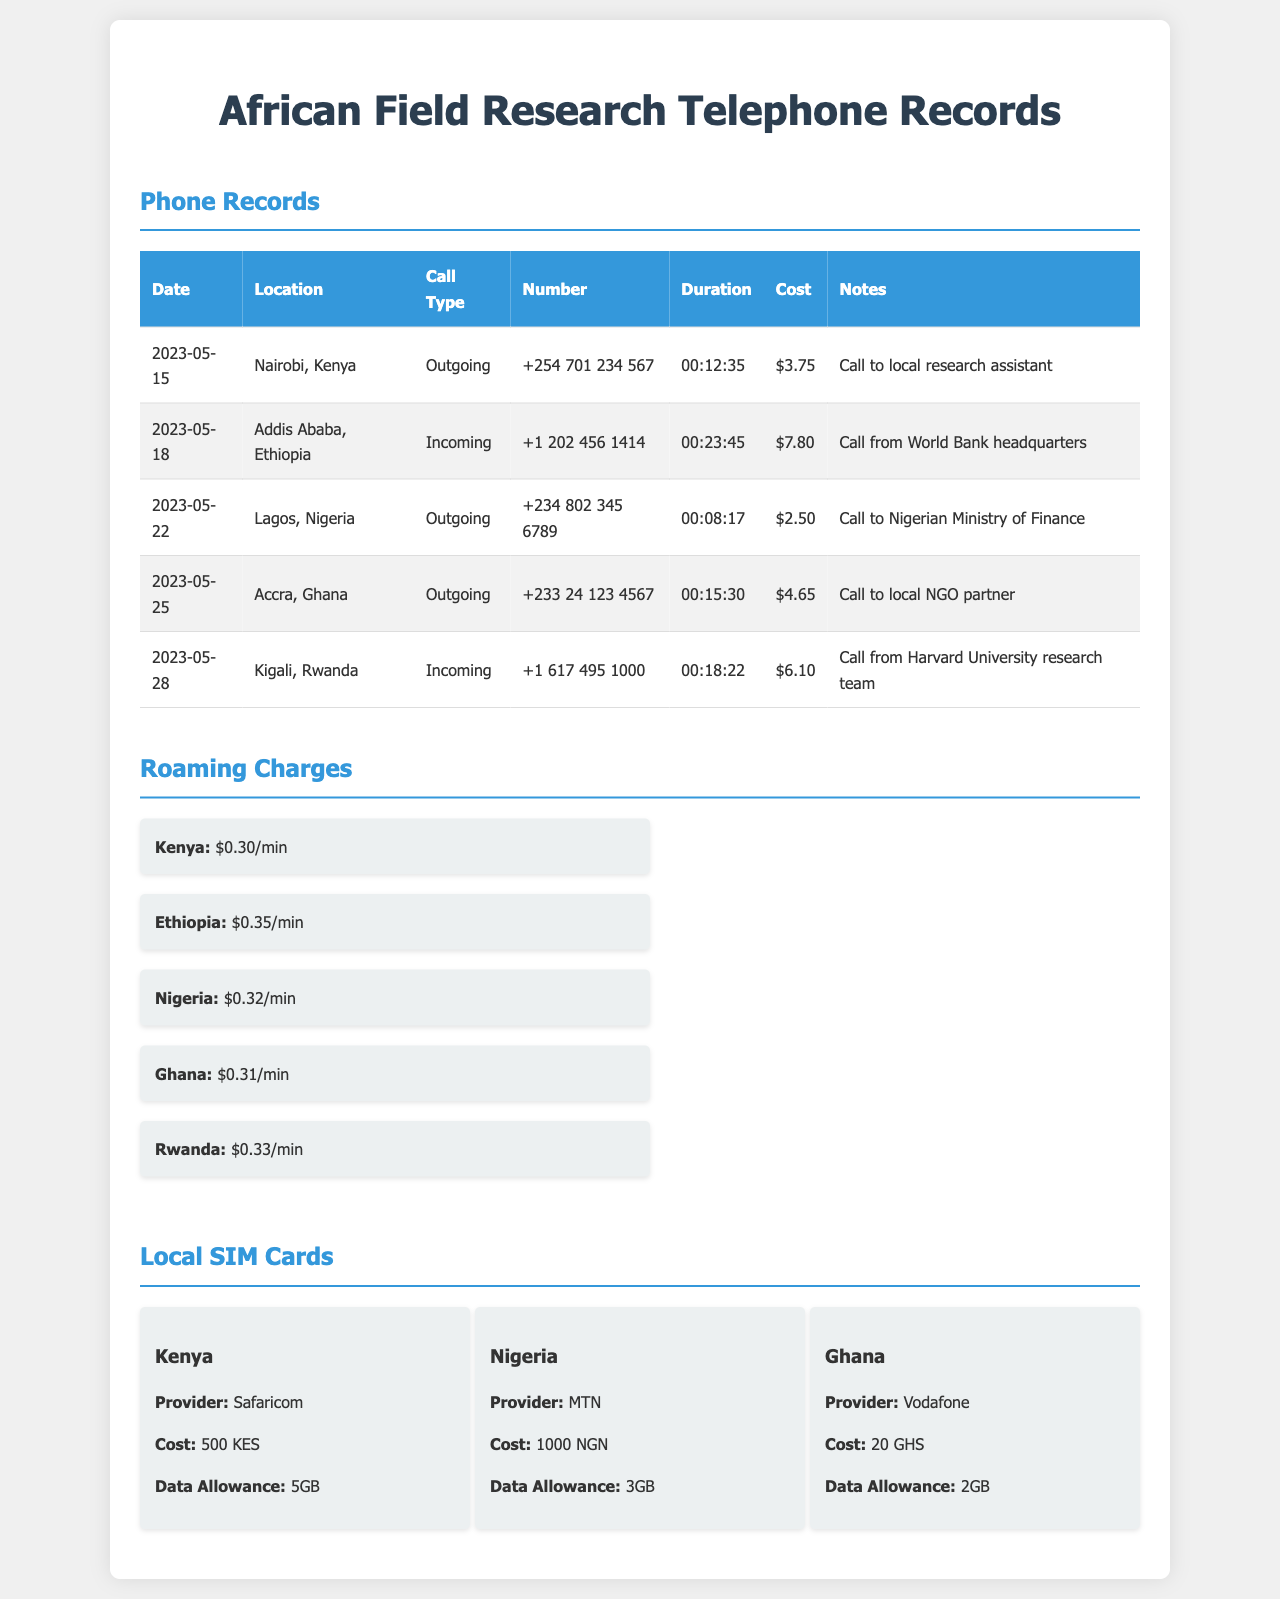What is the total cost of the call to the Nigerian Ministry of Finance? The total cost of the call to the Nigerian Ministry of Finance, made on May 22, 2023, is noted in the document.
Answer: $2.50 Which country had the highest roaming charge per minute? Comparing the roaming charges for each listed country in the document shows which one has the highest rate.
Answer: Ethiopia What was the duration of the call from Harvard University research team? The duration of the call from the Harvard University research team on May 28, 2023, is provided in the document.
Answer: 00:18:22 How much did the local SIM card in Ghana cost? The document specifies the cost of the local SIM card in Ghana.
Answer: 20 GHS What is the data allowance for the local SIM card in Nigeria? The data allowance for the local SIM card provided by MTN in Nigeria is given in the document.
Answer: 3GB Which call type had the least cost recorded? Analyzing all call types in the document helps determine which one had the least recorded cost.
Answer: Outgoing How many minutes were the total outgoing calls from Nairobi? The duration for the outgoing call from Nairobi, listed in the document, can be assumed to inform this total.
Answer: 12 minutes What is the telephone number associated with the call to local NGO partner? The document provides this telephone number in the records table for that specific call.
Answer: +233 24 123 4567 